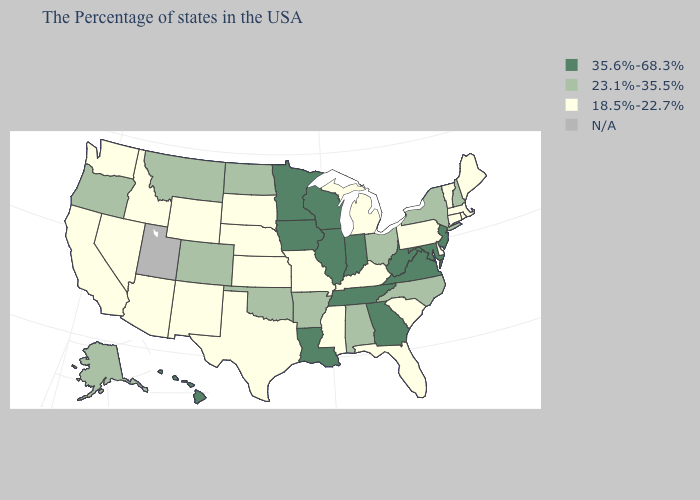How many symbols are there in the legend?
Short answer required. 4. Is the legend a continuous bar?
Write a very short answer. No. Which states have the lowest value in the MidWest?
Short answer required. Michigan, Missouri, Kansas, Nebraska, South Dakota. Which states have the highest value in the USA?
Concise answer only. New Jersey, Maryland, Virginia, West Virginia, Georgia, Indiana, Tennessee, Wisconsin, Illinois, Louisiana, Minnesota, Iowa, Hawaii. Among the states that border North Dakota , which have the lowest value?
Write a very short answer. South Dakota. What is the value of Wyoming?
Answer briefly. 18.5%-22.7%. What is the value of Illinois?
Give a very brief answer. 35.6%-68.3%. What is the highest value in the South ?
Short answer required. 35.6%-68.3%. What is the value of Utah?
Short answer required. N/A. Does the first symbol in the legend represent the smallest category?
Concise answer only. No. What is the highest value in states that border Arizona?
Quick response, please. 23.1%-35.5%. Is the legend a continuous bar?
Short answer required. No. Name the states that have a value in the range 35.6%-68.3%?
Answer briefly. New Jersey, Maryland, Virginia, West Virginia, Georgia, Indiana, Tennessee, Wisconsin, Illinois, Louisiana, Minnesota, Iowa, Hawaii. Name the states that have a value in the range N/A?
Answer briefly. Utah. What is the lowest value in the USA?
Write a very short answer. 18.5%-22.7%. 